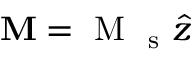<formula> <loc_0><loc_0><loc_500><loc_500>M = M _ { s } \hat { z }</formula> 